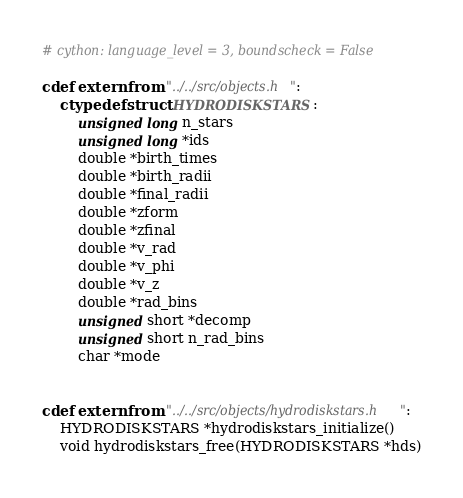Convert code to text. <code><loc_0><loc_0><loc_500><loc_500><_Cython_># cython: language_level = 3, boundscheck = False

cdef extern from "../../src/objects.h":
	ctypedef struct HYDRODISKSTARS:
		unsigned long n_stars
		unsigned long *ids
		double *birth_times
		double *birth_radii
		double *final_radii
		double *zform
		double *zfinal
		double *v_rad
		double *v_phi
		double *v_z
		double *rad_bins
		unsigned short *decomp
		unsigned short n_rad_bins
		char *mode


cdef extern from "../../src/objects/hydrodiskstars.h":
	HYDRODISKSTARS *hydrodiskstars_initialize()
	void hydrodiskstars_free(HYDRODISKSTARS *hds)

</code> 